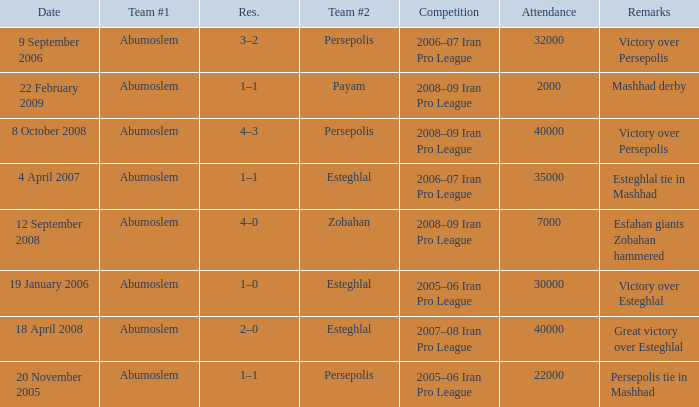What day had an attendance of 22,000? 20 November 2005. 